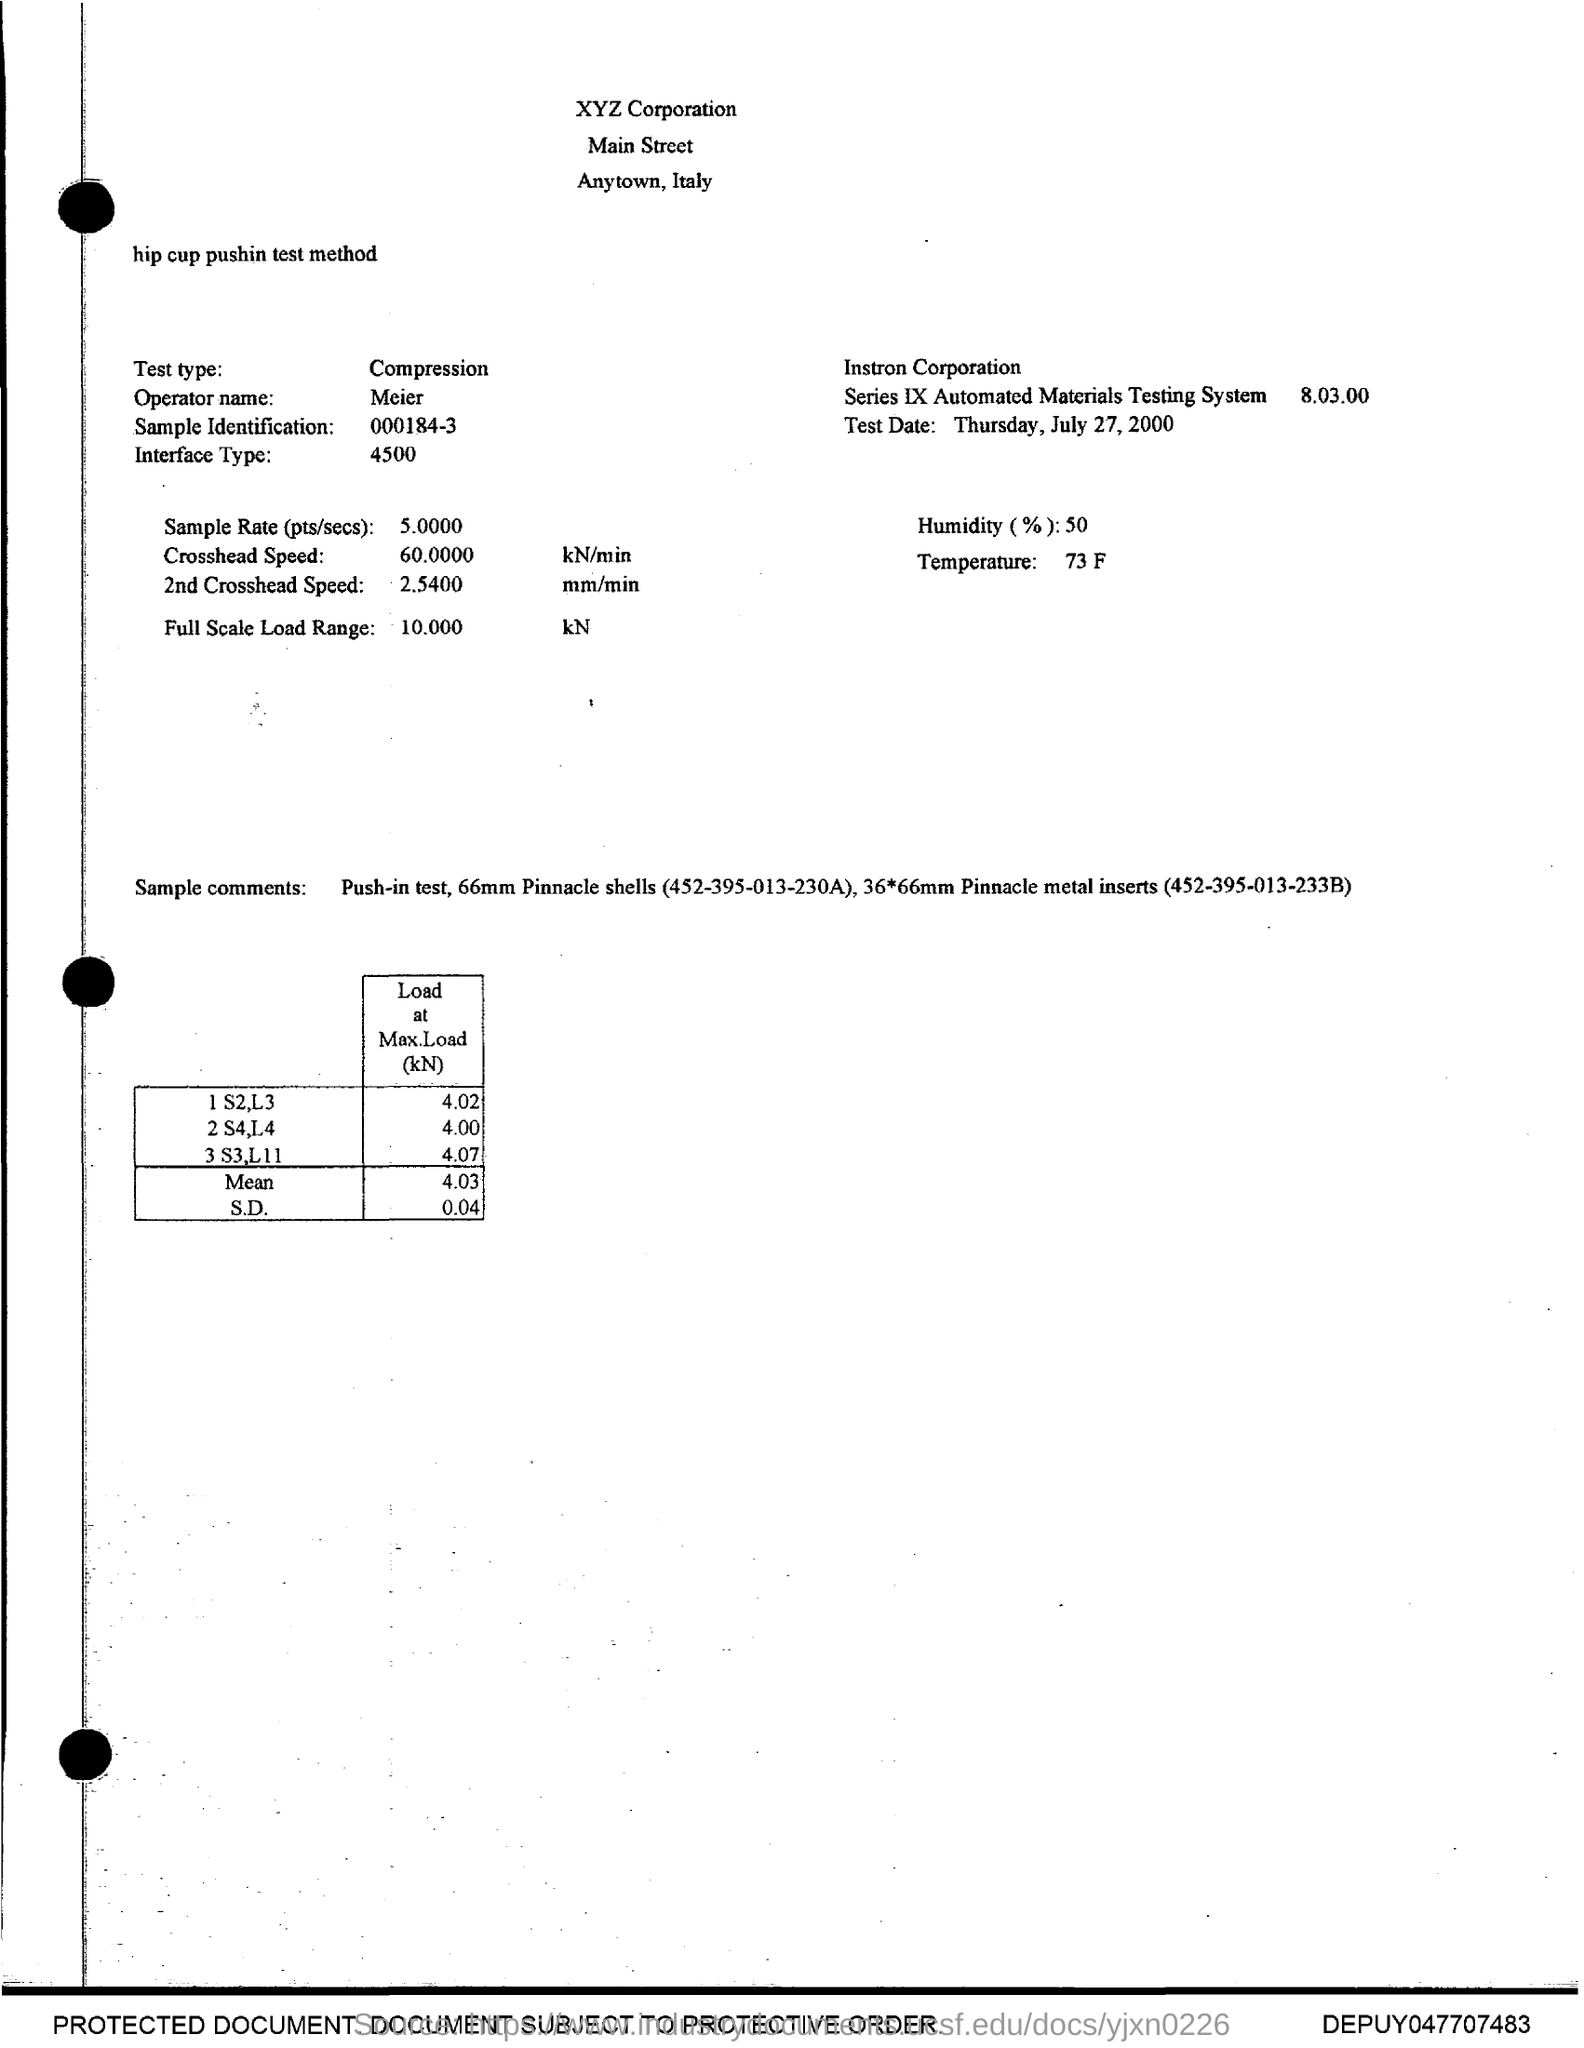What is the temperature?
Provide a succinct answer. 73 f. What is the Humidity?
Provide a succinct answer. 50. What is the test type?
Provide a short and direct response. Compression. What is the name of the Operator?
Keep it short and to the point. Meier. 